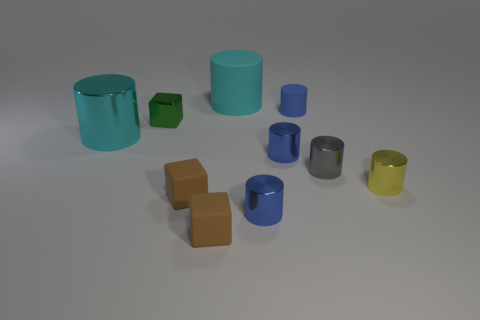Subtract all gray cubes. How many blue cylinders are left? 3 Subtract 1 cylinders. How many cylinders are left? 6 Subtract all big cyan rubber cylinders. How many cylinders are left? 6 Subtract all cyan cylinders. How many cylinders are left? 5 Subtract all green cylinders. Subtract all purple blocks. How many cylinders are left? 7 Subtract all cubes. How many objects are left? 7 Subtract 0 brown balls. How many objects are left? 10 Subtract all yellow metallic cylinders. Subtract all tiny gray objects. How many objects are left? 8 Add 8 large things. How many large things are left? 10 Add 4 blue matte objects. How many blue matte objects exist? 5 